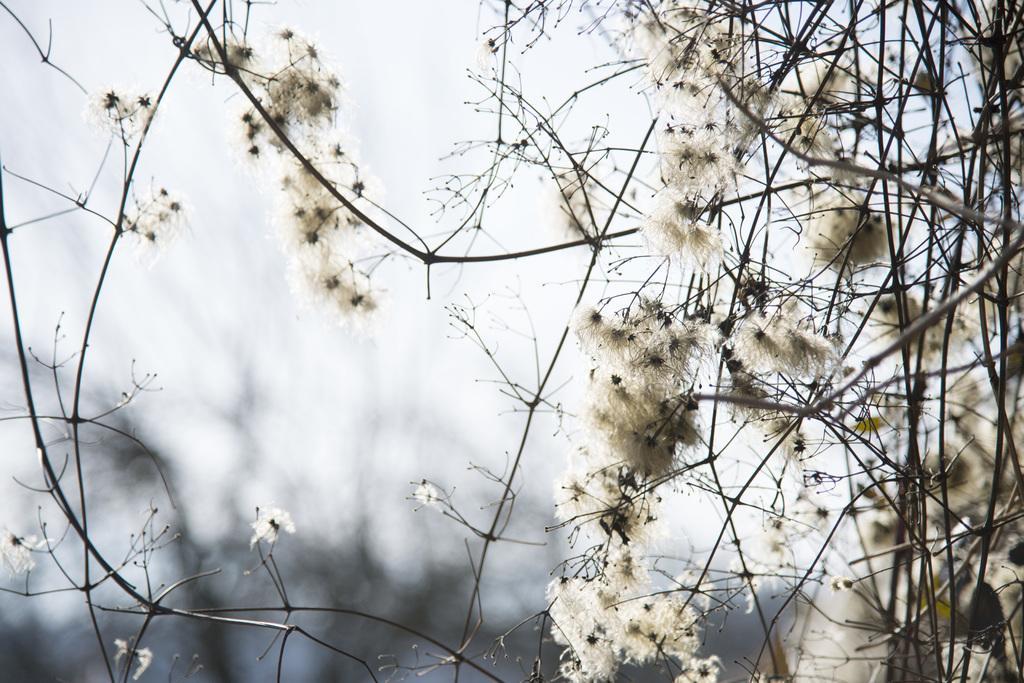Can you describe this image briefly? In this image we can see some trees with flowers on it and the background it is blurred. 